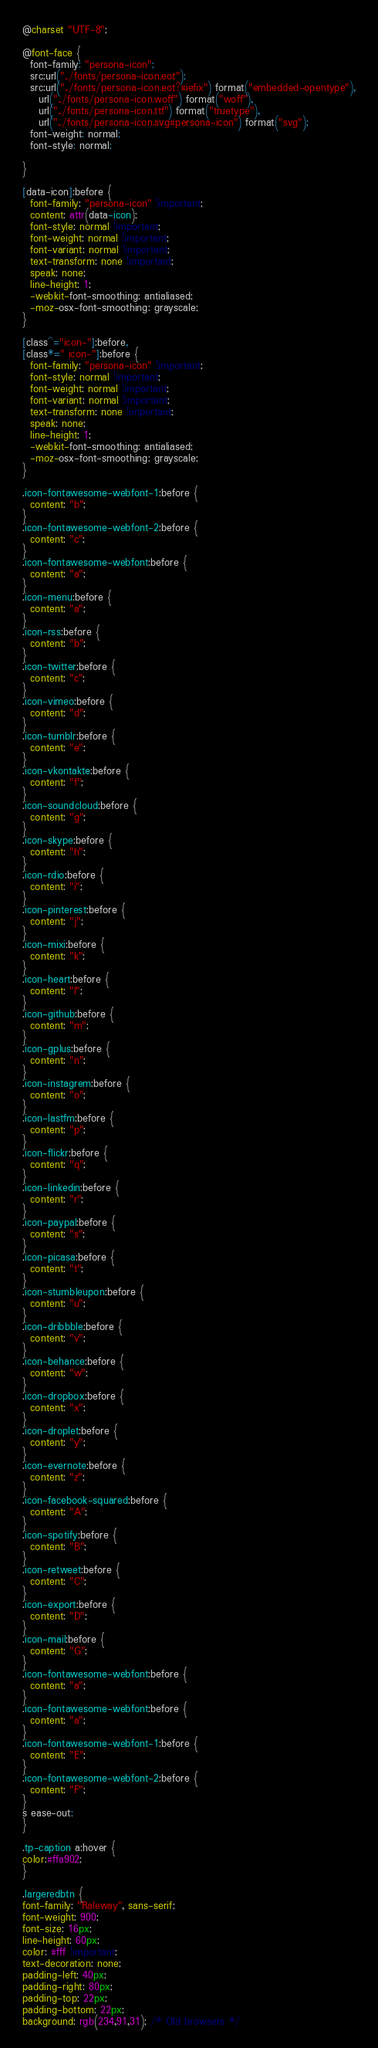Convert code to text. <code><loc_0><loc_0><loc_500><loc_500><_CSS_>@charset "UTF-8";

@font-face {
  font-family: "persona-icon";
  src:url("../fonts/persona-icon.eot");
  src:url("../fonts/persona-icon.eot?#iefix") format("embedded-opentype"),
    url("../fonts/persona-icon.woff") format("woff"),
    url("../fonts/persona-icon.ttf") format("truetype"),
    url("../fonts/persona-icon.svg#persona-icon") format("svg");
  font-weight: normal;
  font-style: normal;

}

[data-icon]:before {
  font-family: "persona-icon" !important;
  content: attr(data-icon);
  font-style: normal !important;
  font-weight: normal !important;
  font-variant: normal !important;
  text-transform: none !important;
  speak: none;
  line-height: 1;
  -webkit-font-smoothing: antialiased;
  -moz-osx-font-smoothing: grayscale;
}

[class^="icon-"]:before,
[class*=" icon-"]:before {
  font-family: "persona-icon" !important;
  font-style: normal !important;
  font-weight: normal !important;
  font-variant: normal !important;
  text-transform: none !important;
  speak: none;
  line-height: 1;
  -webkit-font-smoothing: antialiased;
  -moz-osx-font-smoothing: grayscale;
}

.icon-fontawesome-webfont-1:before {
  content: "b";
}
.icon-fontawesome-webfont-2:before {
  content: "c";
}
.icon-fontawesome-webfont:before {
  content: "a";
}
.icon-menu:before {
  content: "a";
}
.icon-rss:before {
  content: "b";
}
.icon-twitter:before {
  content: "c";
}
.icon-vimeo:before {
  content: "d";
}
.icon-tumblr:before {
  content: "e";
}
.icon-vkontakte:before {
  content: "f";
}
.icon-soundcloud:before {
  content: "g";
}
.icon-skype:before {
  content: "h";
}
.icon-rdio:before {
  content: "i";
}
.icon-pinterest:before {
  content: "j";
}
.icon-mixi:before {
  content: "k";
}
.icon-heart:before {
  content: "l";
}
.icon-github:before {
  content: "m";
}
.icon-gplus:before {
  content: "n";
}
.icon-instagrem:before {
  content: "o";
}
.icon-lastfm:before {
  content: "p";
}
.icon-flickr:before {
  content: "q";
}
.icon-linkedin:before {
  content: "r";
}
.icon-paypal:before {
  content: "s";
}
.icon-picasa:before {
  content: "t";
}
.icon-stumbleupon:before {
  content: "u";
}
.icon-dribbble:before {
  content: "v";
}
.icon-behance:before {
  content: "w";
}
.icon-dropbox:before {
  content: "x";
}
.icon-droplet:before {
  content: "y";
}
.icon-evernote:before {
  content: "z";
}
.icon-facebook-squared:before {
  content: "A";
}
.icon-spotify:before {
  content: "B";
}
.icon-retweet:before {
  content: "C";
}
.icon-export:before {
  content: "D";
}
.icon-mail:before {
  content: "G";
}
.icon-fontawesome-webfont:before {
  content: "a";
}
.icon-fontawesome-webfont:before {
  content: "a";
}
.icon-fontawesome-webfont-1:before {
  content: "E";
}
.icon-fontawesome-webfont-2:before {
  content: "F";
}
s ease-out;
}

.tp-caption a:hover {
color:#ffa902;
}

.largeredbtn {  
font-family: "Raleway", sans-serif;
font-weight: 900;
font-size: 16px;
line-height: 60px;
color: #fff !important;
text-decoration: none;
padding-left: 40px;
padding-right: 80px;
padding-top: 22px;
padding-bottom: 22px;
background: rgb(234,91,31); /* Old browsers */</code> 